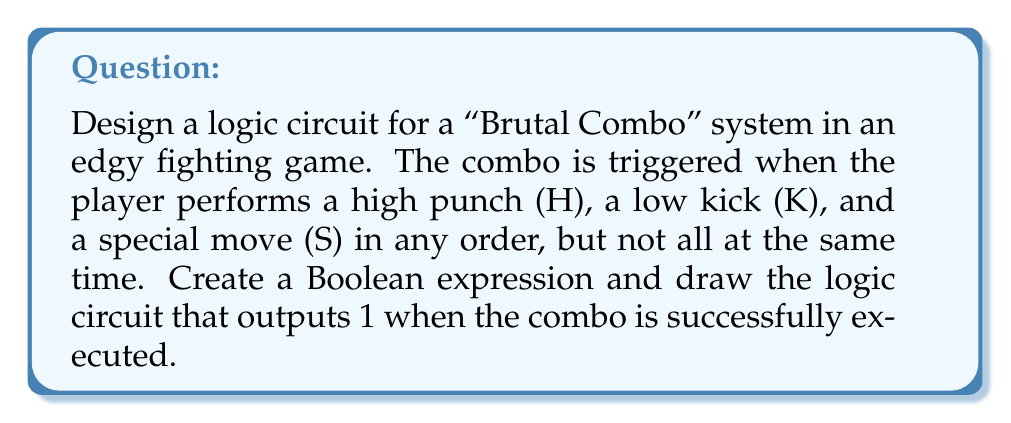What is the answer to this math problem? Let's approach this step-by-step:

1) We need to detect when at least two of the three inputs are active. This can be represented by the Boolean expression:

   $$(H \cdot K) + (H \cdot S) + (K \cdot S)$$

2) However, we don't want all three inputs to be active simultaneously. We can represent this condition as:

   $\overline{(H \cdot K \cdot S)}$

3) Combining these conditions, our final Boolean expression is:

   $$((H \cdot K) + (H \cdot S) + (K \cdot S)) \cdot \overline{(H \cdot K \cdot S)}$$

4) To simplify this, let's use $X = (H \cdot K) + (H \cdot S) + (K \cdot S)$. Then our expression becomes:

   $$X \cdot \overline{(H \cdot K \cdot S)}$$

5) Now, let's draw the logic circuit:

[asy]
unitsize(30);
defaultpen(fontsize(10pt));

// Inputs
label("H", (-1,5));
label("K", (-1,3));
label("S", (-1,1));

// AND gates for X
draw((-0.5,4.5)--(-0.5,5.5)--(0.5,5.5)--(0.5,4.5)--cycle);
draw((0,5)--(1,5));
label("&", (0,5));

draw((-0.5,2.5)--(-0.5,3.5)--(0.5,3.5)--(0.5,2.5)--cycle);
draw((0,3)--(1,3));
label("&", (0,3));

draw((-0.5,0.5)--(-0.5,1.5)--(0.5,1.5)--(0.5,0.5)--cycle);
draw((0,1)--(1,1));
label("&", (0,1));

// OR gate for X
draw((1.5,3.5)--(1.5,5.5)--(2.5,5)--(2.5,4)--(1.5,3.5));
draw((2.5,4.5)--(3.5,4.5));
label("≥1", (2,4.5));

// AND gate for H·K·S
draw((1.5,1.5)--(1.5,2.5)--(2.5,2.5)--(2.5,1.5)--cycle);
draw((2.5,2)--(3.5,2));
label("&", (2,2));

// NOT gate
draw((4,1.5)--(4,2.5)--(5,2)--(4,1.5));
draw((5,2)--(6,2));
label("1", (4.5,2));

// Final AND gate
draw((6.5,3)--(6.5,4)--(7.5,4)--(7.5,3)--cycle);
draw((7.5,3.5)--(8.5,3.5));
label("&", (7,3.5));

// Connections
draw((-1,5)--(-0.5,5));
draw((-1,3)--(-0.5,3));
draw((-1,1)--(-0.5,1));

draw((-1,5)--(1.5,5.5));
draw((-1,3)--(1.5,4.5));
draw((1,5)--(1.5,5));
draw((1,3)--(1.5,4));
draw((1,1)--(1.5,3.5));

draw((-1,5)--(1.5,2.5));
draw((-1,3)--(1.5,2));
draw((-1,1)--(1.5,1.5));

draw((3.5,4.5)--(6.5,3.5));
draw((3.5,2)--(4,2));
draw((6,2)--(6.5,3));

label("Output", (8.5,3.5), E);
[/asy]

This circuit implements the Boolean expression we derived, triggering the "Brutal Combo" when two or more inputs are active, but not all three simultaneously.
Answer: $((H \cdot K) + (H \cdot S) + (K \cdot S)) \cdot \overline{(H \cdot K \cdot S)}$ 